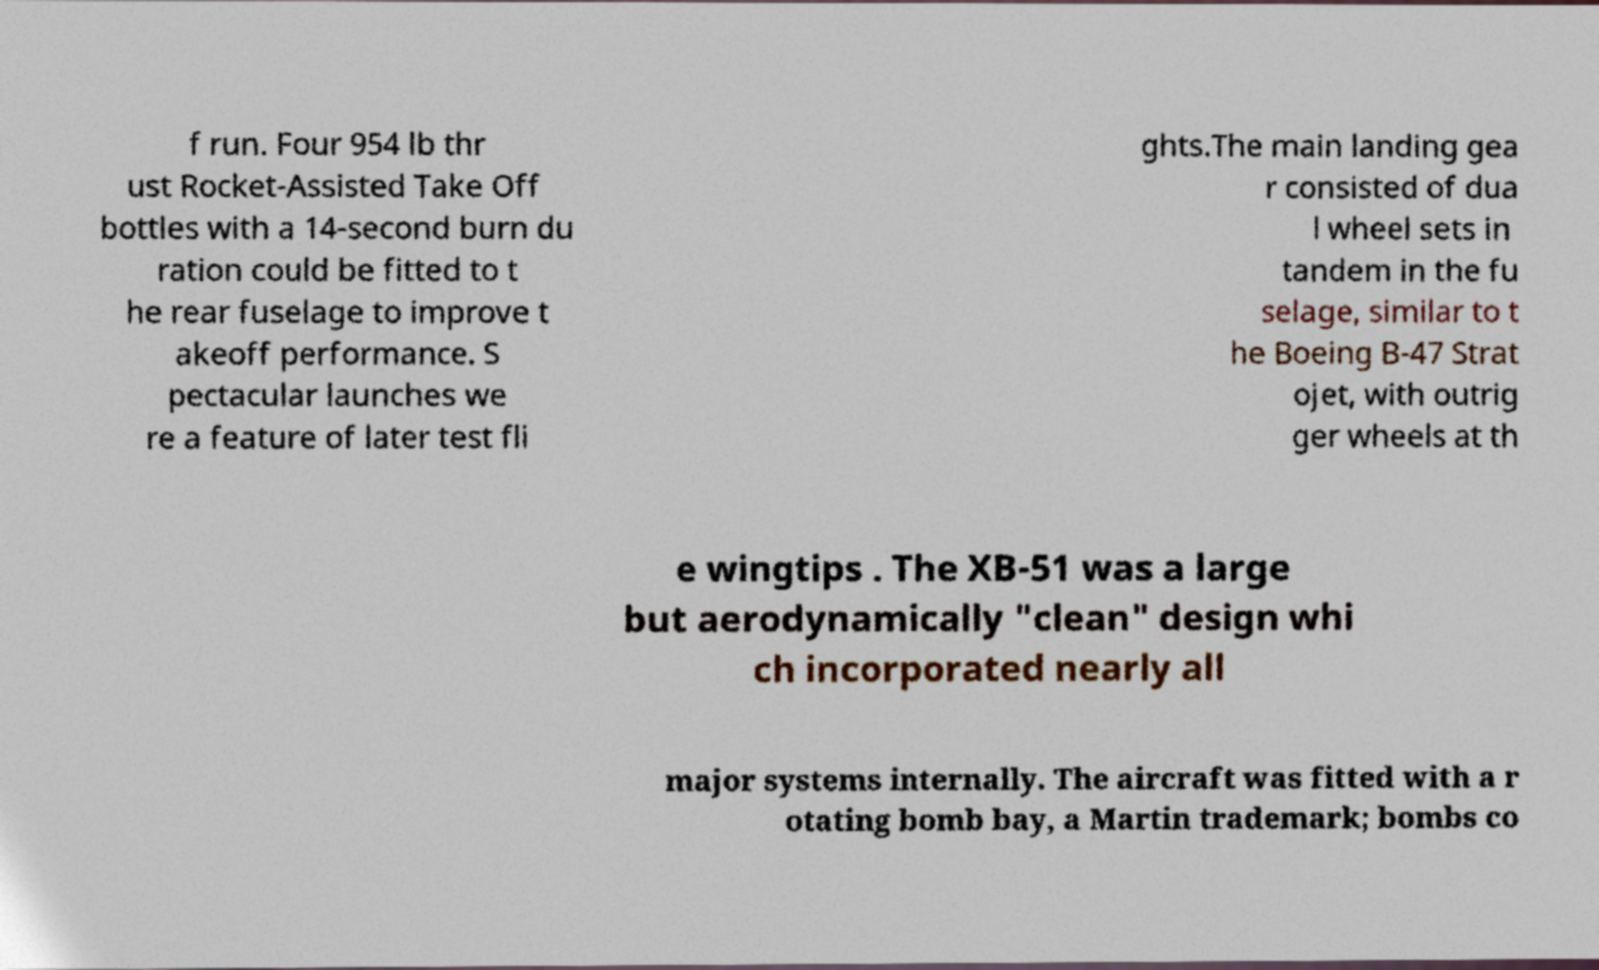Could you extract and type out the text from this image? f run. Four 954 lb thr ust Rocket-Assisted Take Off bottles with a 14-second burn du ration could be fitted to t he rear fuselage to improve t akeoff performance. S pectacular launches we re a feature of later test fli ghts.The main landing gea r consisted of dua l wheel sets in tandem in the fu selage, similar to t he Boeing B-47 Strat ojet, with outrig ger wheels at th e wingtips . The XB-51 was a large but aerodynamically "clean" design whi ch incorporated nearly all major systems internally. The aircraft was fitted with a r otating bomb bay, a Martin trademark; bombs co 